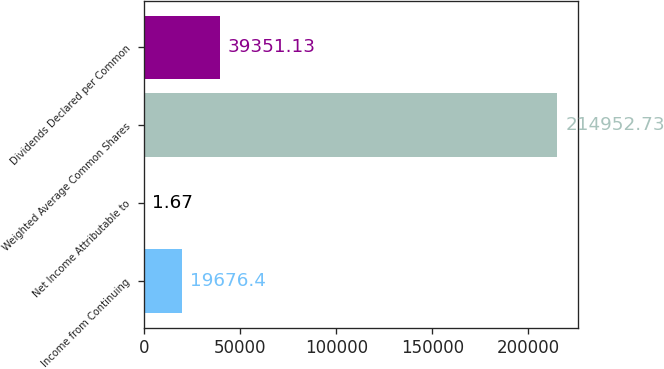Convert chart. <chart><loc_0><loc_0><loc_500><loc_500><bar_chart><fcel>Income from Continuing<fcel>Net Income Attributable to<fcel>Weighted Average Common Shares<fcel>Dividends Declared per Common<nl><fcel>19676.4<fcel>1.67<fcel>214953<fcel>39351.1<nl></chart> 